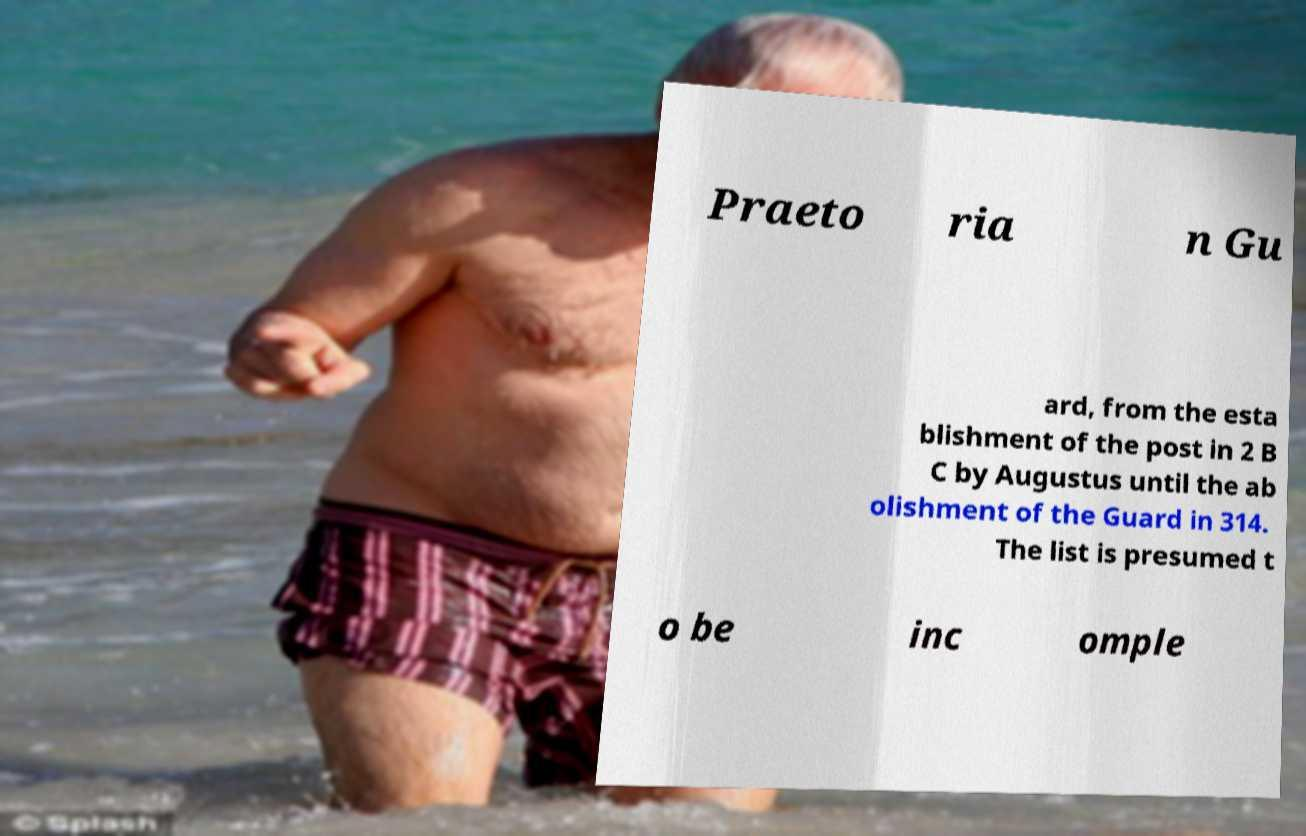For documentation purposes, I need the text within this image transcribed. Could you provide that? Praeto ria n Gu ard, from the esta blishment of the post in 2 B C by Augustus until the ab olishment of the Guard in 314. The list is presumed t o be inc omple 